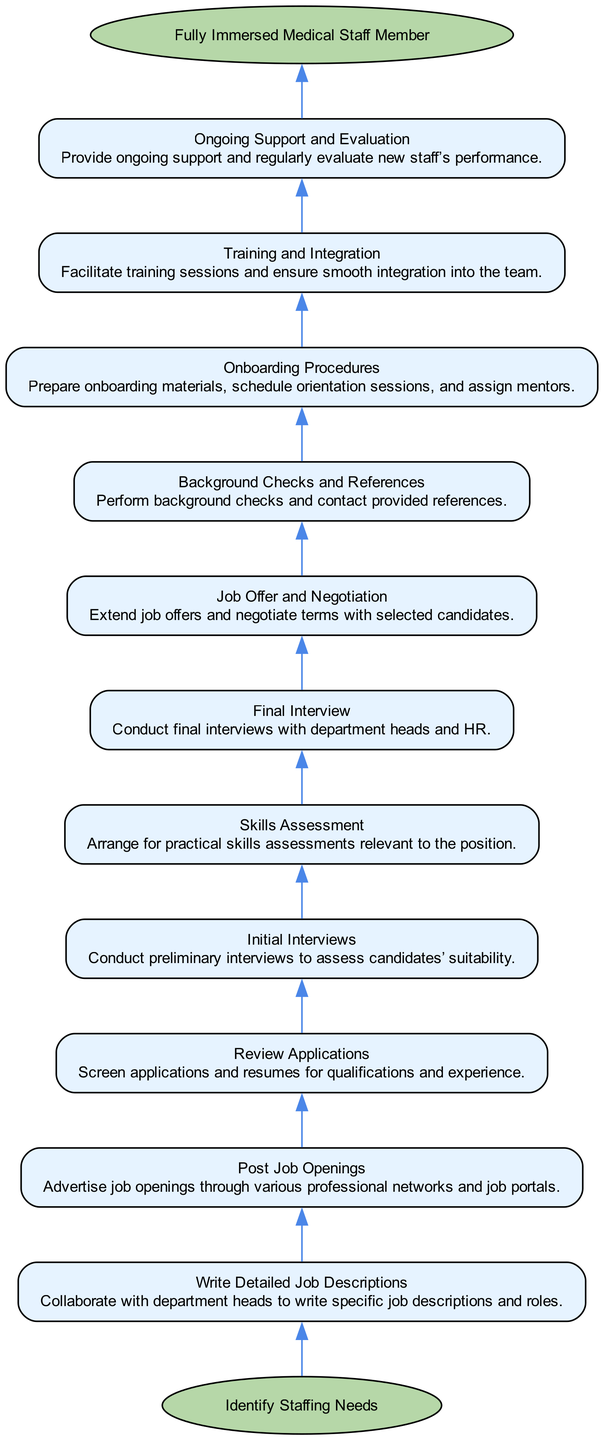What is the start step in this onboarding process? The onboarding process starts with "Identify Staffing Needs," which is the first node connected to the start node. This indicates the initial action for onboarding new medical staff.
Answer: Identify Staffing Needs How many steps are there in the onboarding process? By counting the individual steps listed in the diagram's details, there are 10 distinct steps involved before reaching the end node.
Answer: 10 What does the final step in this process represent? The final step, labeled as "Fully Immersed Medical Staff Member," indicates the successful conclusion of the onboarding process and the expected outcome of integrating new staff.
Answer: Fully Immersed Medical Staff Member Which step directly follows "Initial Interviews"? Following "Initial Interviews," the next step listed is "Skills Assessment," showing the progression from assessing candidates in interviews to evaluating their practical skills.
Answer: Skills Assessment What is the relationship between "Job Offer and Negotiation" and "Background Checks and References"? "Job Offer and Negotiation" comes before "Background Checks and References," indicating that job offers are extended prior to conducting background checks and referencing for the selected candidates.
Answer: Job Offer and Negotiation -> Background Checks and References How many edges connect the steps in this diagram? There are 11 edges in total, with each step connected to the next and two additional edges connecting the start node to the first step and the last step to the end node.
Answer: 11 What step does "Ongoing Support and Evaluation" lead to? The step "Ongoing Support and Evaluation" leads to the end node "Fully Immersed Medical Staff Member," showing that ongoing support ensures a successful completion of the onboarding process.
Answer: Fully Immersed Medical Staff Member Which step involves collaborating with department heads? The step titled "Write Detailed Job Descriptions" specifically involves collaboration with department heads to create job descriptions, emphasizing teamwork in the onboarding process.
Answer: Write Detailed Job Descriptions What type of assessment is associated with the step following "Skills Assessment"? The next step after "Skills Assessment" is "Final Interview," indicating that practical assessments of skills are followed by final evaluations in interviews.
Answer: Final Interview 